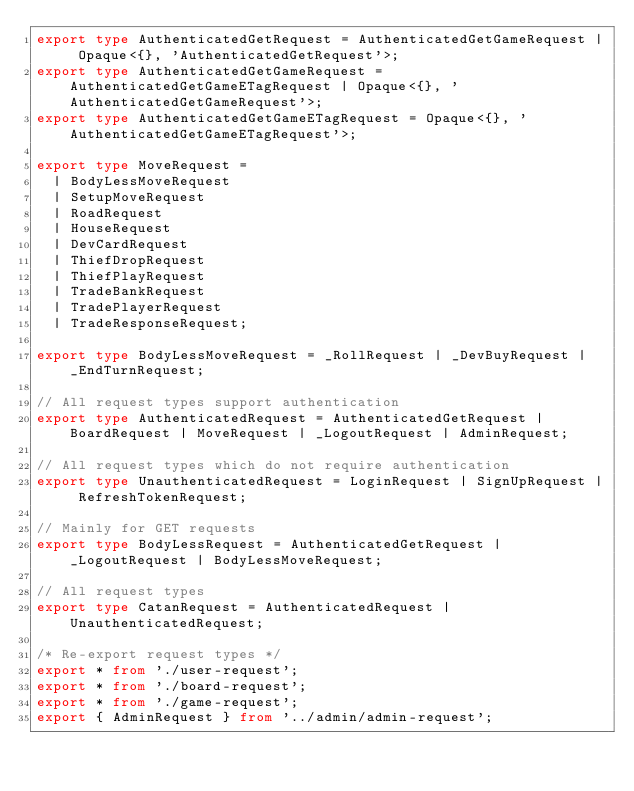Convert code to text. <code><loc_0><loc_0><loc_500><loc_500><_TypeScript_>export type AuthenticatedGetRequest = AuthenticatedGetGameRequest | Opaque<{}, 'AuthenticatedGetRequest'>;
export type AuthenticatedGetGameRequest = AuthenticatedGetGameETagRequest | Opaque<{}, 'AuthenticatedGetGameRequest'>;
export type AuthenticatedGetGameETagRequest = Opaque<{}, 'AuthenticatedGetGameETagRequest'>;

export type MoveRequest =
  | BodyLessMoveRequest
  | SetupMoveRequest
  | RoadRequest
  | HouseRequest
  | DevCardRequest
  | ThiefDropRequest
  | ThiefPlayRequest
  | TradeBankRequest
  | TradePlayerRequest
  | TradeResponseRequest;

export type BodyLessMoveRequest = _RollRequest | _DevBuyRequest | _EndTurnRequest;

// All request types support authentication
export type AuthenticatedRequest = AuthenticatedGetRequest | BoardRequest | MoveRequest | _LogoutRequest | AdminRequest;

// All request types which do not require authentication
export type UnauthenticatedRequest = LoginRequest | SignUpRequest | RefreshTokenRequest;

// Mainly for GET requests
export type BodyLessRequest = AuthenticatedGetRequest | _LogoutRequest | BodyLessMoveRequest;

// All request types
export type CatanRequest = AuthenticatedRequest | UnauthenticatedRequest;

/* Re-export request types */
export * from './user-request';
export * from './board-request';
export * from './game-request';
export { AdminRequest } from '../admin/admin-request';
</code> 